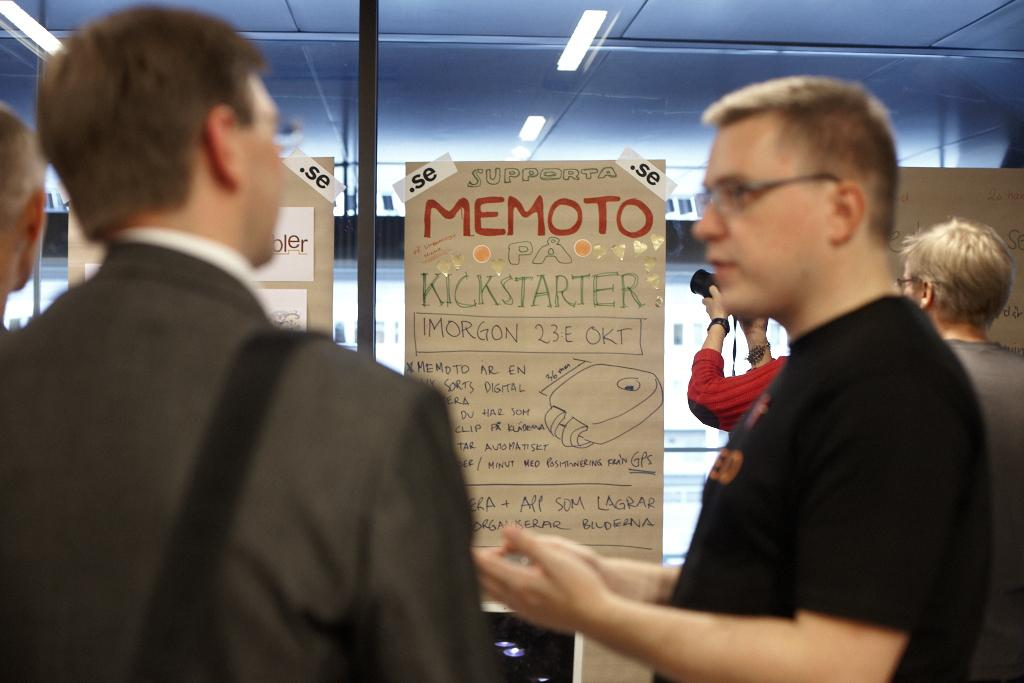What is displayed on the glass wall in the image? There are charts on a glass wall in the image. Can you describe the person on the right side of the image? There is a person holding a camera on the right side of the image. Are there any other people visible in the image? Yes, there are people visible in the image. Is there a partner holding a jar in the quicksand in the image? There is no partner, jar, or quicksand present in the image. 